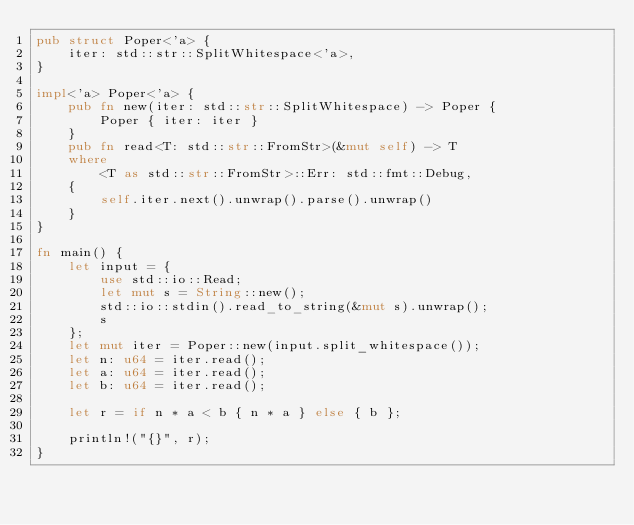Convert code to text. <code><loc_0><loc_0><loc_500><loc_500><_Rust_>pub struct Poper<'a> {
	iter: std::str::SplitWhitespace<'a>,
}

impl<'a> Poper<'a> {
	pub fn new(iter: std::str::SplitWhitespace) -> Poper {
		Poper { iter: iter }
	}
	pub fn read<T: std::str::FromStr>(&mut self) -> T
	where
		<T as std::str::FromStr>::Err: std::fmt::Debug,
	{
		self.iter.next().unwrap().parse().unwrap()
	}
}

fn main() {
	let input = {
		use std::io::Read;
		let mut s = String::new();
		std::io::stdin().read_to_string(&mut s).unwrap();
		s
	};
	let mut iter = Poper::new(input.split_whitespace());
	let n: u64 = iter.read();
	let a: u64 = iter.read();
	let b: u64 = iter.read();

	let r = if n * a < b { n * a } else { b };

	println!("{}", r);
}
</code> 